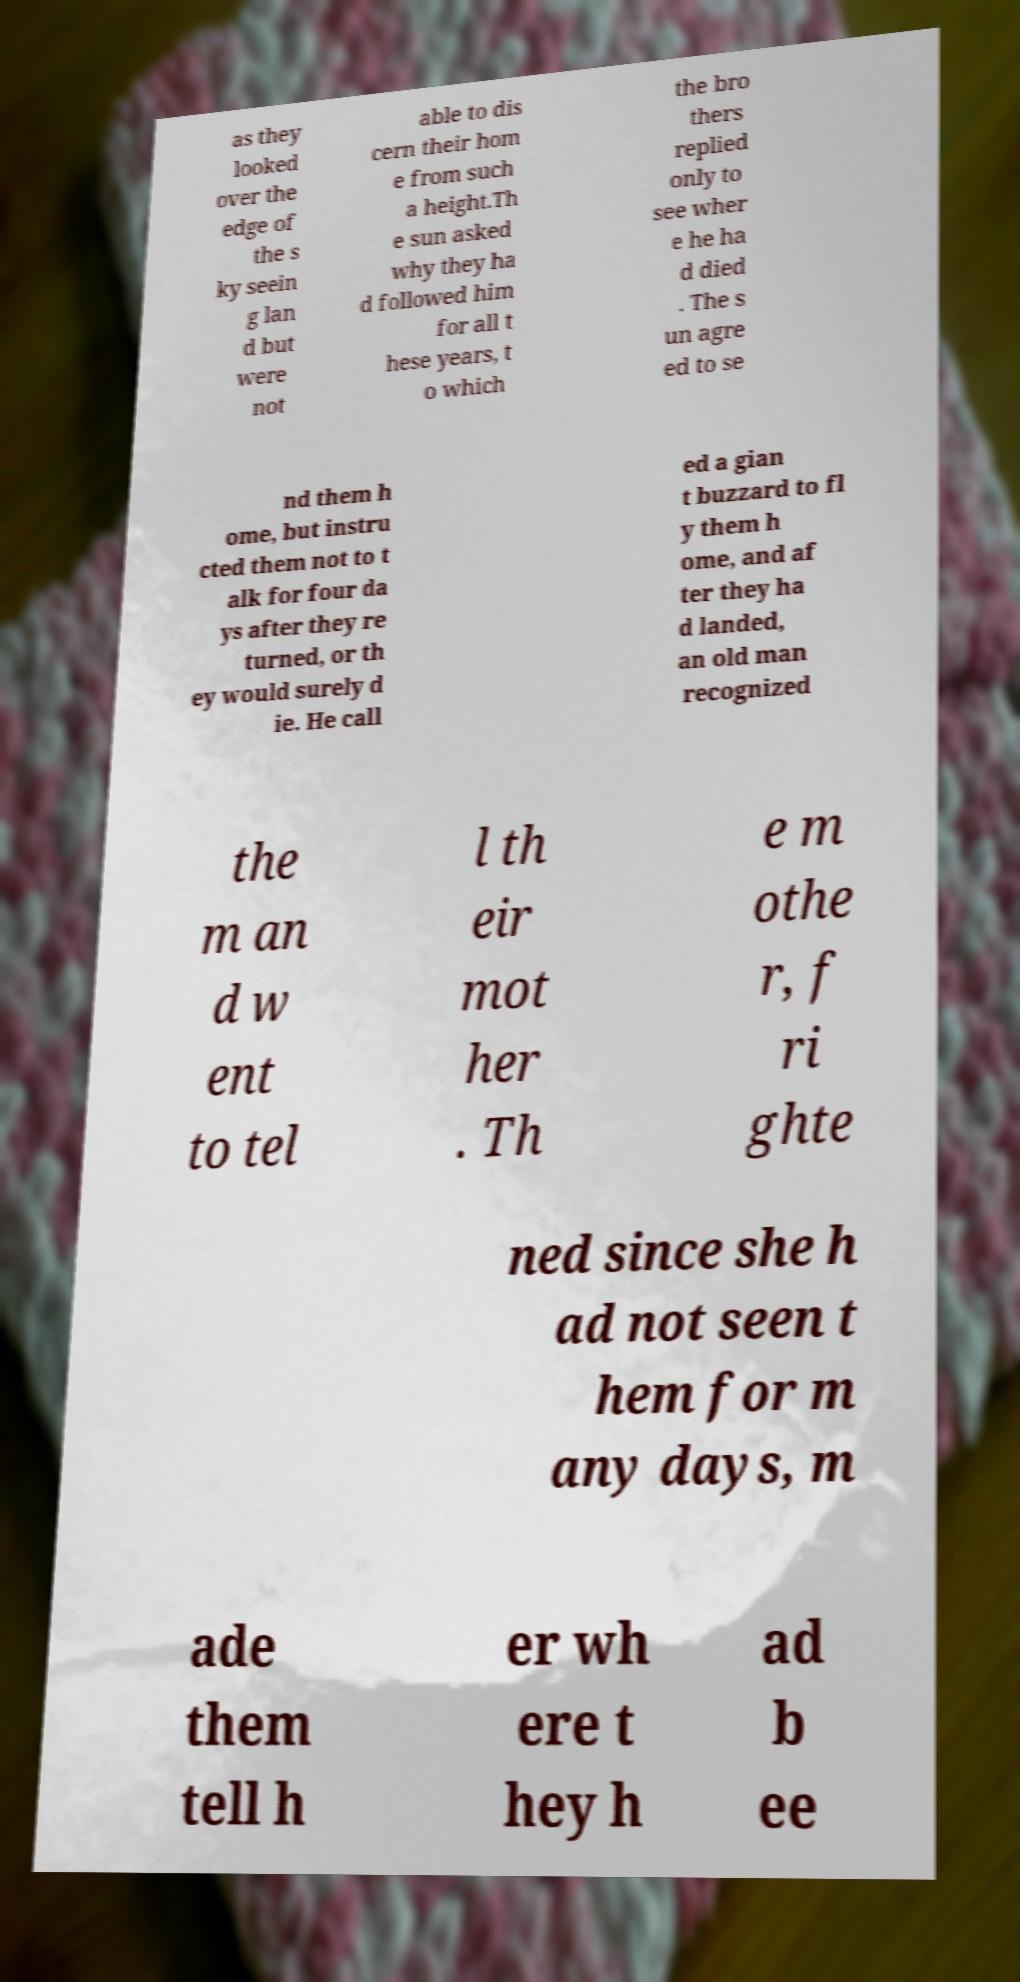For documentation purposes, I need the text within this image transcribed. Could you provide that? as they looked over the edge of the s ky seein g lan d but were not able to dis cern their hom e from such a height.Th e sun asked why they ha d followed him for all t hese years, t o which the bro thers replied only to see wher e he ha d died . The s un agre ed to se nd them h ome, but instru cted them not to t alk for four da ys after they re turned, or th ey would surely d ie. He call ed a gian t buzzard to fl y them h ome, and af ter they ha d landed, an old man recognized the m an d w ent to tel l th eir mot her . Th e m othe r, f ri ghte ned since she h ad not seen t hem for m any days, m ade them tell h er wh ere t hey h ad b ee 